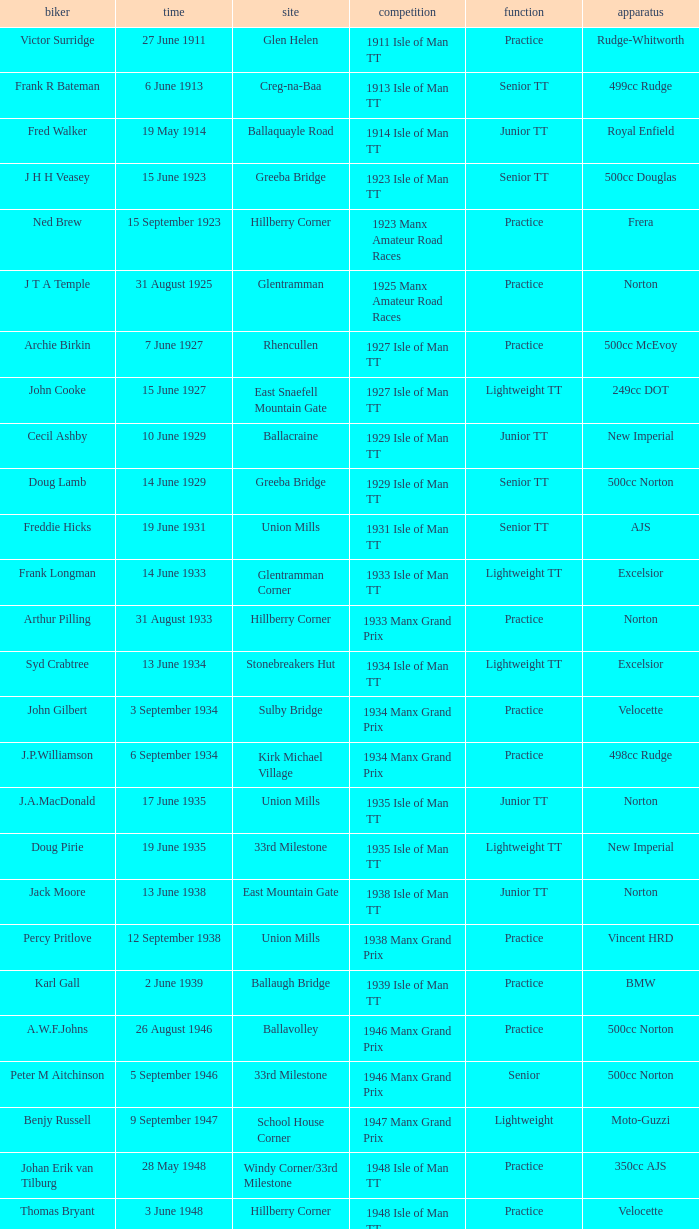Where was the 249cc Yamaha? Glentramman. 